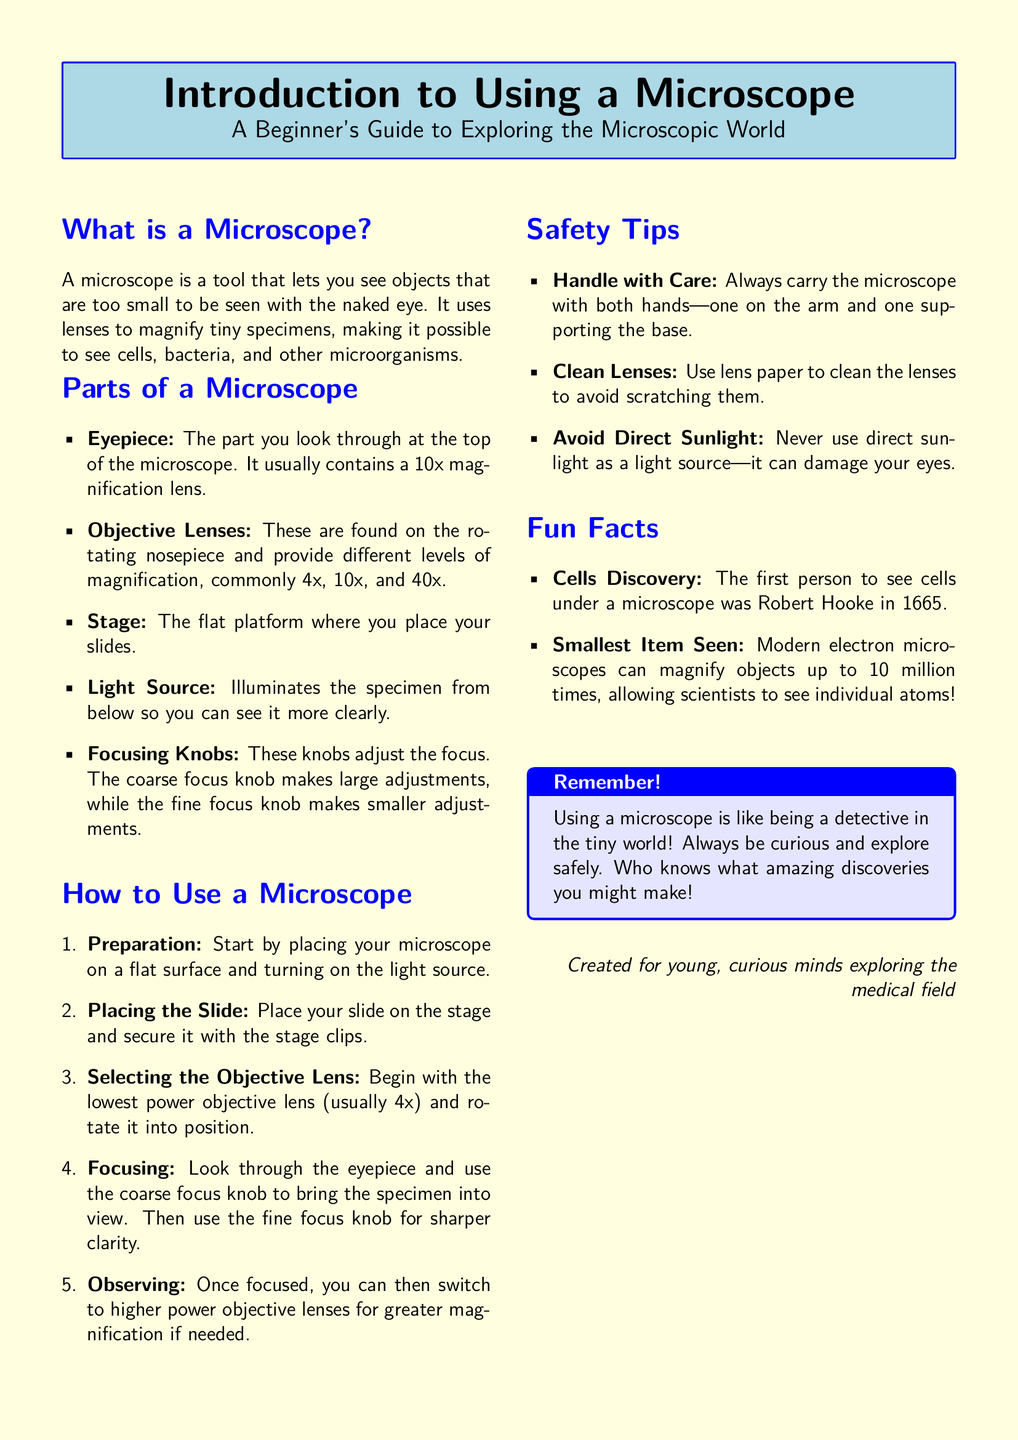What is the main tool discussed in the document? The document focuses on a tool that allows users to see tiny objects not visible to the naked eye, highlighting its function as a magnifying device.
Answer: Microscope What is the magnification level of the eyepiece? The document specifies that the eyepiece typically contains a lens that provides a 10x magnification level.
Answer: 10x What should be done before placing the slide on the stage? The guide instructs to place the microscope on a flat surface and turn on the light source before placing the slide.
Answer: Preparation What is the highest power objective lens mentioned? The document lists the commonly used objective lenses, with 40x being the highest power objective lens mentioned.
Answer: 40x What famous scientist first observed cells under a microscope? The document references Robert Hooke as the first person to see cells under a microscope in 1665.
Answer: Robert Hooke What two focusing knobs are used for adjustments? The guide clearly differentiates between the coarse focus knob for large adjustments and the fine focus knob for smaller adjustments.
Answer: Coarse and fine focus knobs What is a critical safety tip provided? The document emphasizes the importance of handling the microscope with care to avoid accidents during use.
Answer: Handle with care What unique aspect does electron microscopy allow scientists to observe? The document mentions that modern electron microscopes can magnify objects to a degree that allows visualization of individual atoms.
Answer: Individual atoms What feeling does the document encourage about exploration? The concluding advice within the document encourages curiosity and exploration, inviting users to embrace the adventure of discovery.
Answer: Curiosity 